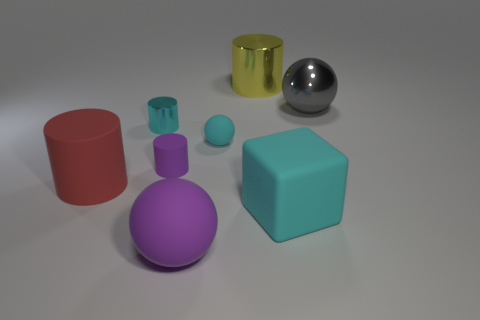There is a rubber block that is the same color as the small metal thing; what is its size?
Keep it short and to the point. Large. There is a gray metal object that is on the right side of the cyan ball; is it the same size as the rubber sphere to the right of the large purple object?
Keep it short and to the point. No. What is the size of the purple thing that is in front of the big cyan block?
Offer a very short reply. Large. Is there a tiny thing that has the same color as the small metal cylinder?
Provide a short and direct response. Yes. There is a yellow object; is its size the same as the cyan object that is behind the tiny cyan rubber object?
Keep it short and to the point. No. Is the size of the purple matte cylinder the same as the red thing?
Your answer should be very brief. No. What number of things are red rubber objects or tiny cyan objects?
Provide a succinct answer. 3. There is a purple thing that is the same shape as the large gray metallic object; what is its size?
Give a very brief answer. Large. What is the size of the matte cube?
Your answer should be very brief. Large. Is the number of small metal objects that are behind the yellow thing greater than the number of large brown metal objects?
Give a very brief answer. No. 